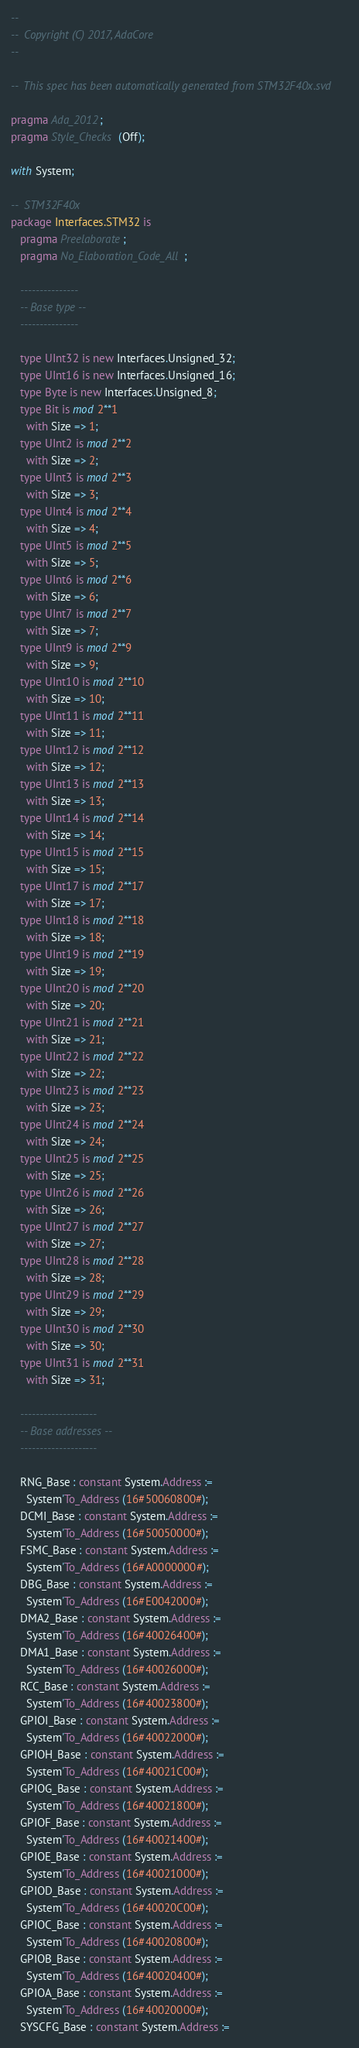Convert code to text. <code><loc_0><loc_0><loc_500><loc_500><_Ada_>--
--  Copyright (C) 2017, AdaCore
--

--  This spec has been automatically generated from STM32F40x.svd

pragma Ada_2012;
pragma Style_Checks (Off);

with System;

--  STM32F40x
package Interfaces.STM32 is
   pragma Preelaborate;
   pragma No_Elaboration_Code_All;

   ---------------
   -- Base type --
   ---------------

   type UInt32 is new Interfaces.Unsigned_32;
   type UInt16 is new Interfaces.Unsigned_16;
   type Byte is new Interfaces.Unsigned_8;
   type Bit is mod 2**1
     with Size => 1;
   type UInt2 is mod 2**2
     with Size => 2;
   type UInt3 is mod 2**3
     with Size => 3;
   type UInt4 is mod 2**4
     with Size => 4;
   type UInt5 is mod 2**5
     with Size => 5;
   type UInt6 is mod 2**6
     with Size => 6;
   type UInt7 is mod 2**7
     with Size => 7;
   type UInt9 is mod 2**9
     with Size => 9;
   type UInt10 is mod 2**10
     with Size => 10;
   type UInt11 is mod 2**11
     with Size => 11;
   type UInt12 is mod 2**12
     with Size => 12;
   type UInt13 is mod 2**13
     with Size => 13;
   type UInt14 is mod 2**14
     with Size => 14;
   type UInt15 is mod 2**15
     with Size => 15;
   type UInt17 is mod 2**17
     with Size => 17;
   type UInt18 is mod 2**18
     with Size => 18;
   type UInt19 is mod 2**19
     with Size => 19;
   type UInt20 is mod 2**20
     with Size => 20;
   type UInt21 is mod 2**21
     with Size => 21;
   type UInt22 is mod 2**22
     with Size => 22;
   type UInt23 is mod 2**23
     with Size => 23;
   type UInt24 is mod 2**24
     with Size => 24;
   type UInt25 is mod 2**25
     with Size => 25;
   type UInt26 is mod 2**26
     with Size => 26;
   type UInt27 is mod 2**27
     with Size => 27;
   type UInt28 is mod 2**28
     with Size => 28;
   type UInt29 is mod 2**29
     with Size => 29;
   type UInt30 is mod 2**30
     with Size => 30;
   type UInt31 is mod 2**31
     with Size => 31;

   --------------------
   -- Base addresses --
   --------------------

   RNG_Base : constant System.Address :=
     System'To_Address (16#50060800#);
   DCMI_Base : constant System.Address :=
     System'To_Address (16#50050000#);
   FSMC_Base : constant System.Address :=
     System'To_Address (16#A0000000#);
   DBG_Base : constant System.Address :=
     System'To_Address (16#E0042000#);
   DMA2_Base : constant System.Address :=
     System'To_Address (16#40026400#);
   DMA1_Base : constant System.Address :=
     System'To_Address (16#40026000#);
   RCC_Base : constant System.Address :=
     System'To_Address (16#40023800#);
   GPIOI_Base : constant System.Address :=
     System'To_Address (16#40022000#);
   GPIOH_Base : constant System.Address :=
     System'To_Address (16#40021C00#);
   GPIOG_Base : constant System.Address :=
     System'To_Address (16#40021800#);
   GPIOF_Base : constant System.Address :=
     System'To_Address (16#40021400#);
   GPIOE_Base : constant System.Address :=
     System'To_Address (16#40021000#);
   GPIOD_Base : constant System.Address :=
     System'To_Address (16#40020C00#);
   GPIOC_Base : constant System.Address :=
     System'To_Address (16#40020800#);
   GPIOB_Base : constant System.Address :=
     System'To_Address (16#40020400#);
   GPIOA_Base : constant System.Address :=
     System'To_Address (16#40020000#);
   SYSCFG_Base : constant System.Address :=</code> 